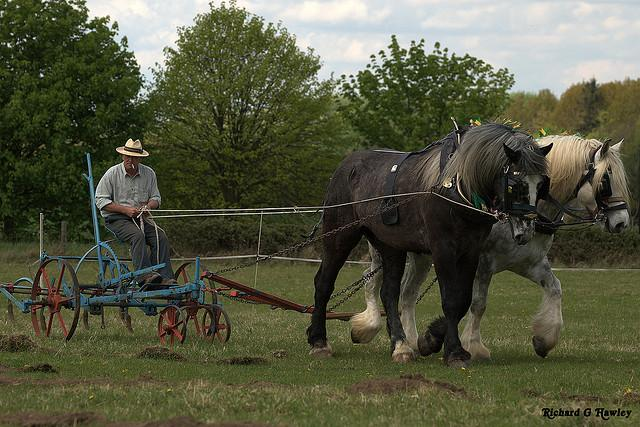What is he doing? plowing 